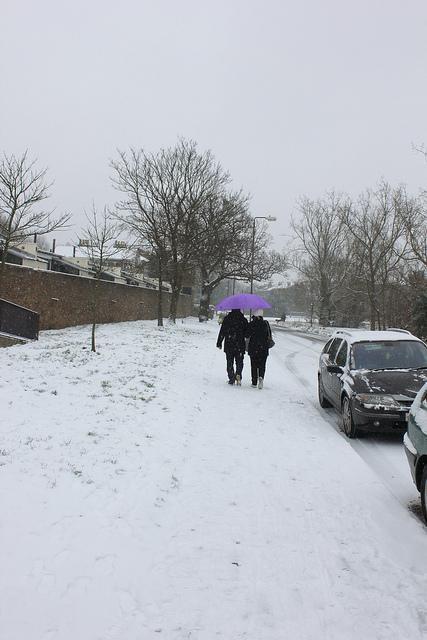How many people are walking?
Give a very brief answer. 2. How many people are riding bikes here?
Give a very brief answer. 0. How many giraffes in this photo?
Give a very brief answer. 0. 